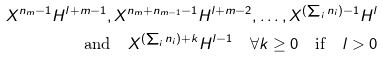<formula> <loc_0><loc_0><loc_500><loc_500>X ^ { n _ { m } - 1 } H ^ { l + m - 1 } , X ^ { n _ { m } + n _ { m - 1 } - 1 } H ^ { l + m - 2 } , \dots , X ^ { ( \sum _ { i } n _ { i } ) - 1 } H ^ { l } \\ \text {and} \quad X ^ { ( \sum _ { i } n _ { i } ) + k } H ^ { l - 1 } \quad \forall k \geq 0 \quad \text {if} \quad l > 0</formula> 